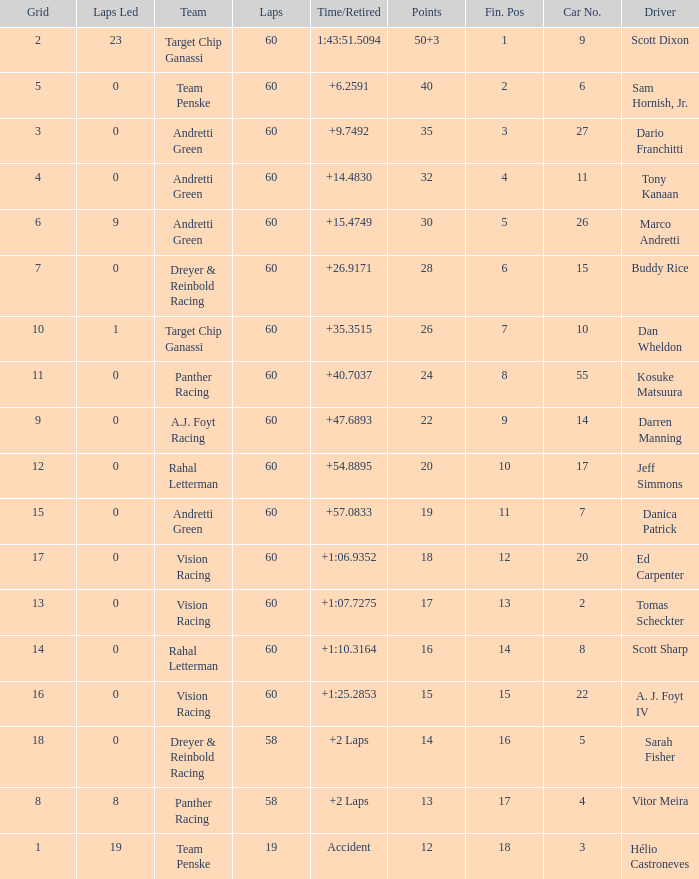Which team does darren manning belong to? A.J. Foyt Racing. 